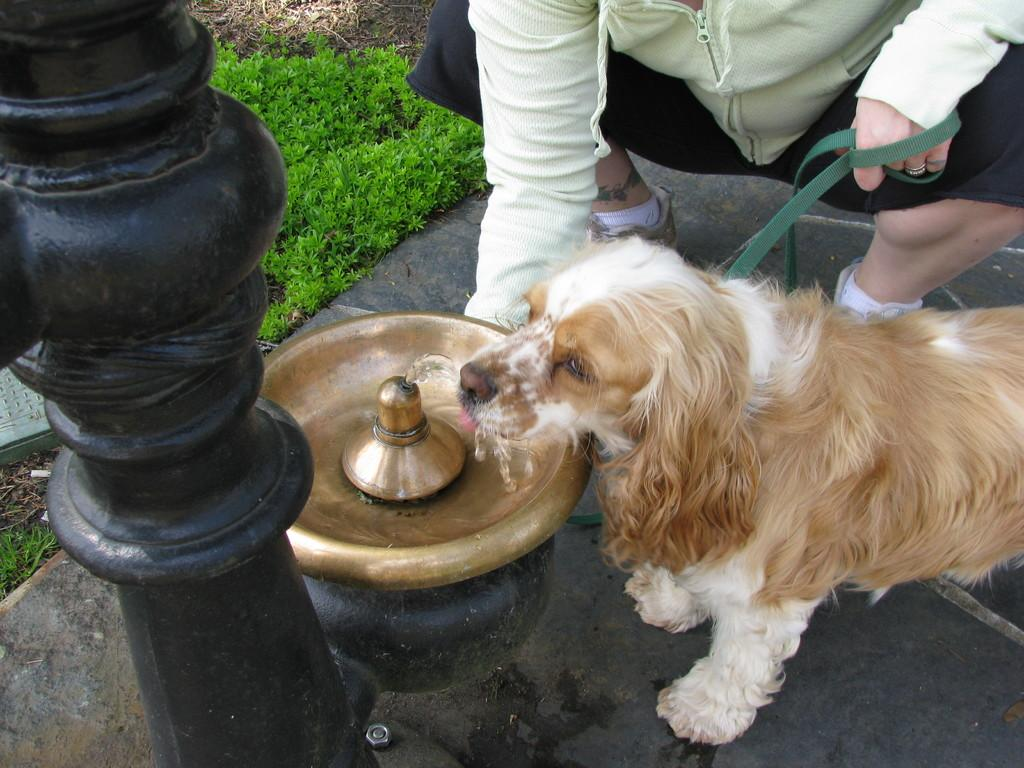What type of animal is in the image? There is an animal in the image, but the specific type cannot be determined from the provided facts. What is the container holding in the image? There is a container with water in the image. What is the pole used for in the image? The purpose of the pole in the image cannot be determined from the provided facts. What type of vegetation is present in the image? There is grass in the image. What is the person in the image doing? There is a person sitting in the image, but their specific activity cannot be determined from the provided facts. What grade did the person in the image receive on their joke? There is no information about a joke or a grade in the image, so this question cannot be answered. 